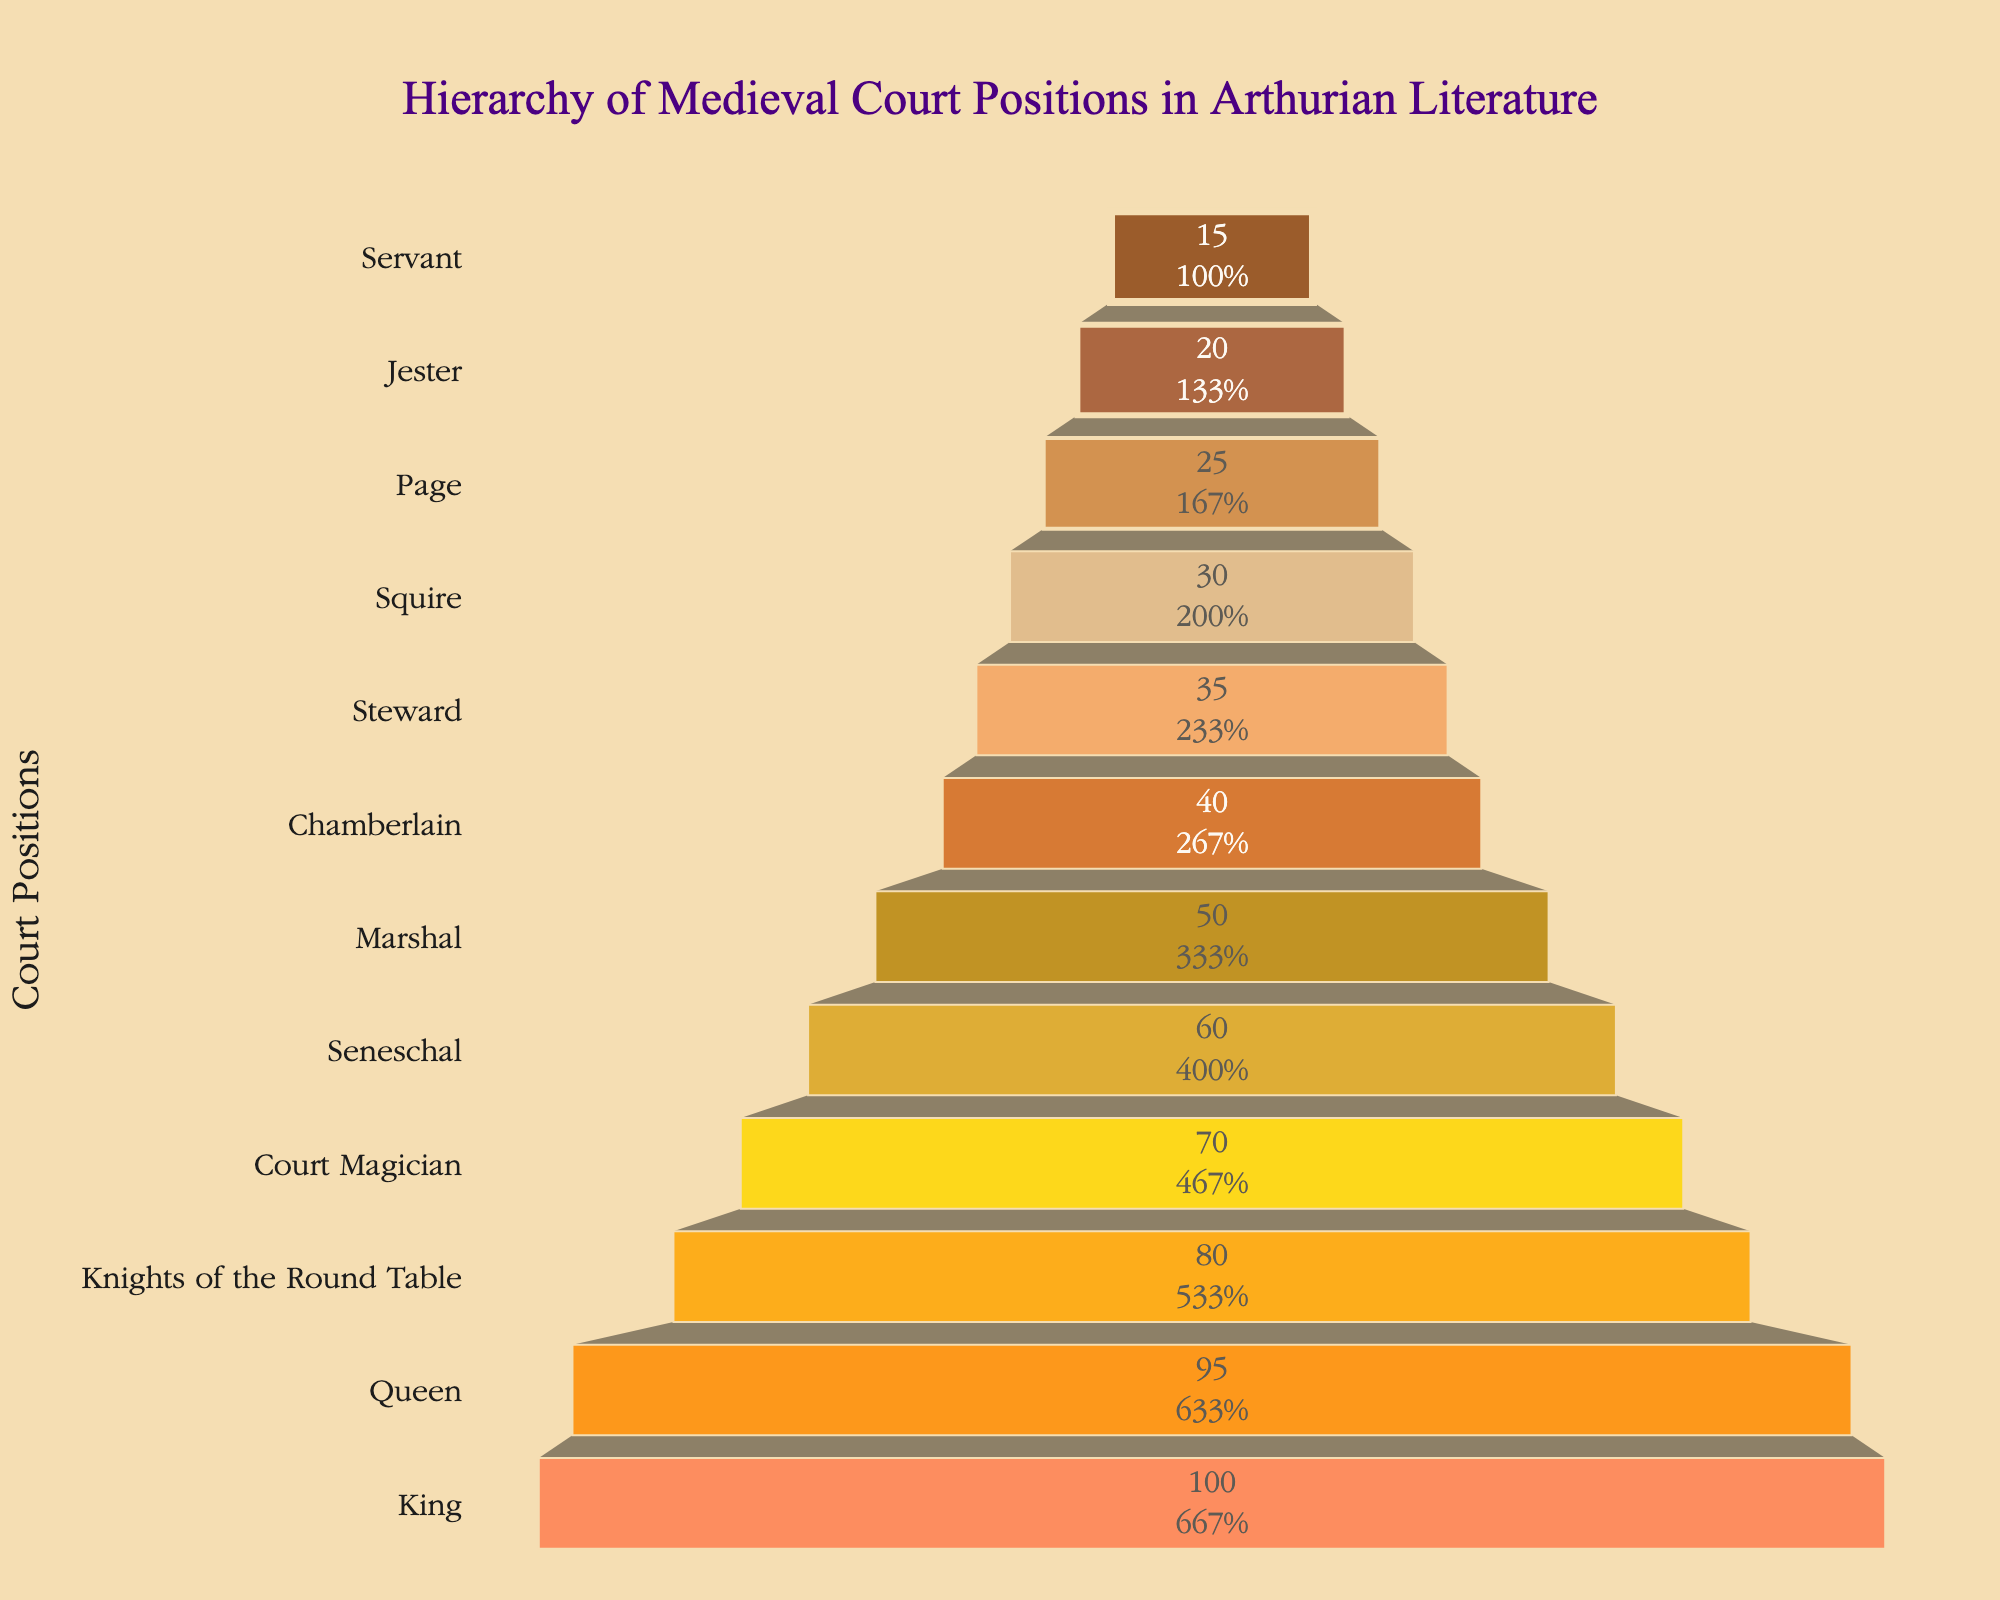what is the title of the figure? The title is usually displayed at the top of the figure. In this case, it reads "Hierarchy of Medieval Court Positions in Arthurian Literature."
Answer: Hierarchy of Medieval Court Positions in Arthurian Literature How many court positions are displayed in the funnel chart? Count the unique positions listed on the y-axis of the funnel chart. There are 12 positions listed from "King" down to "Servant."
Answer: 12 Which court position has the highest frequency? The court position at the widest part of the funnel has the highest frequency. Here, it is the "King" with a frequency of 100.
Answer: King What is the frequency of the Queen? Look at the corresponding segment for "Queen" in the funnel chart, which has a frequency of 95.
Answer: 95 Which court position is directly below the "Squire"? Find "Squire" on the y-axis and look at the position listed directly beneath it, which is "Page."
Answer: Page What is the difference in frequency between the "Knights of the Round Table" and "Servant"? Subtract the frequency of "Servant" (15) from the frequency of "Knights of the Round Table" (80): 80 - 15 = 65.
Answer: 65 What are the two court positions with the lowest frequencies? Identify the narrowest segments at the bottom of the funnel, which correspond to "Jester" (20) and "Servant" (15).
Answer: Jester and Servant What is the combined frequency of the "Marshal" and "Seneschal"? Add the frequencies of "Marshal" (50) and "Seneschal" (60): 50 + 60 = 110.
Answer: 110 How many positions have a frequency higher than 50? Count the segments with frequencies greater than 50: "King" (100), "Queen" (95), "Knights of the Round Table" (80), "Court Magician" (70), and "Seneschal" (60). There are 5 positions.
Answer: 5 How does the chart visually represent the relationship between rank and frequency? The width of the segments decreases progressively from top to bottom, indicating higher frequencies at the top (higher ranks) and lower frequencies at the bottom (lower ranks).
Answer: Decreasing width from top to bottom 